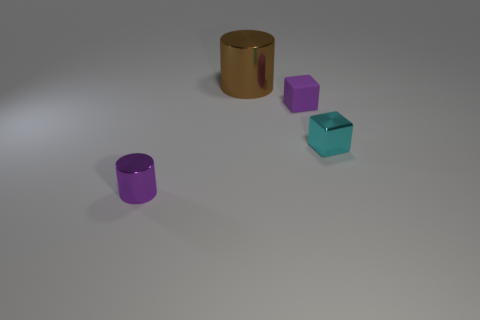Subtract all purple cylinders. Subtract all gray blocks. How many cylinders are left? 1 Add 2 small cyan metallic cubes. How many objects exist? 6 Add 1 purple rubber blocks. How many purple rubber blocks exist? 2 Subtract 0 gray blocks. How many objects are left? 4 Subtract all small rubber blocks. Subtract all purple things. How many objects are left? 1 Add 3 tiny cylinders. How many tiny cylinders are left? 4 